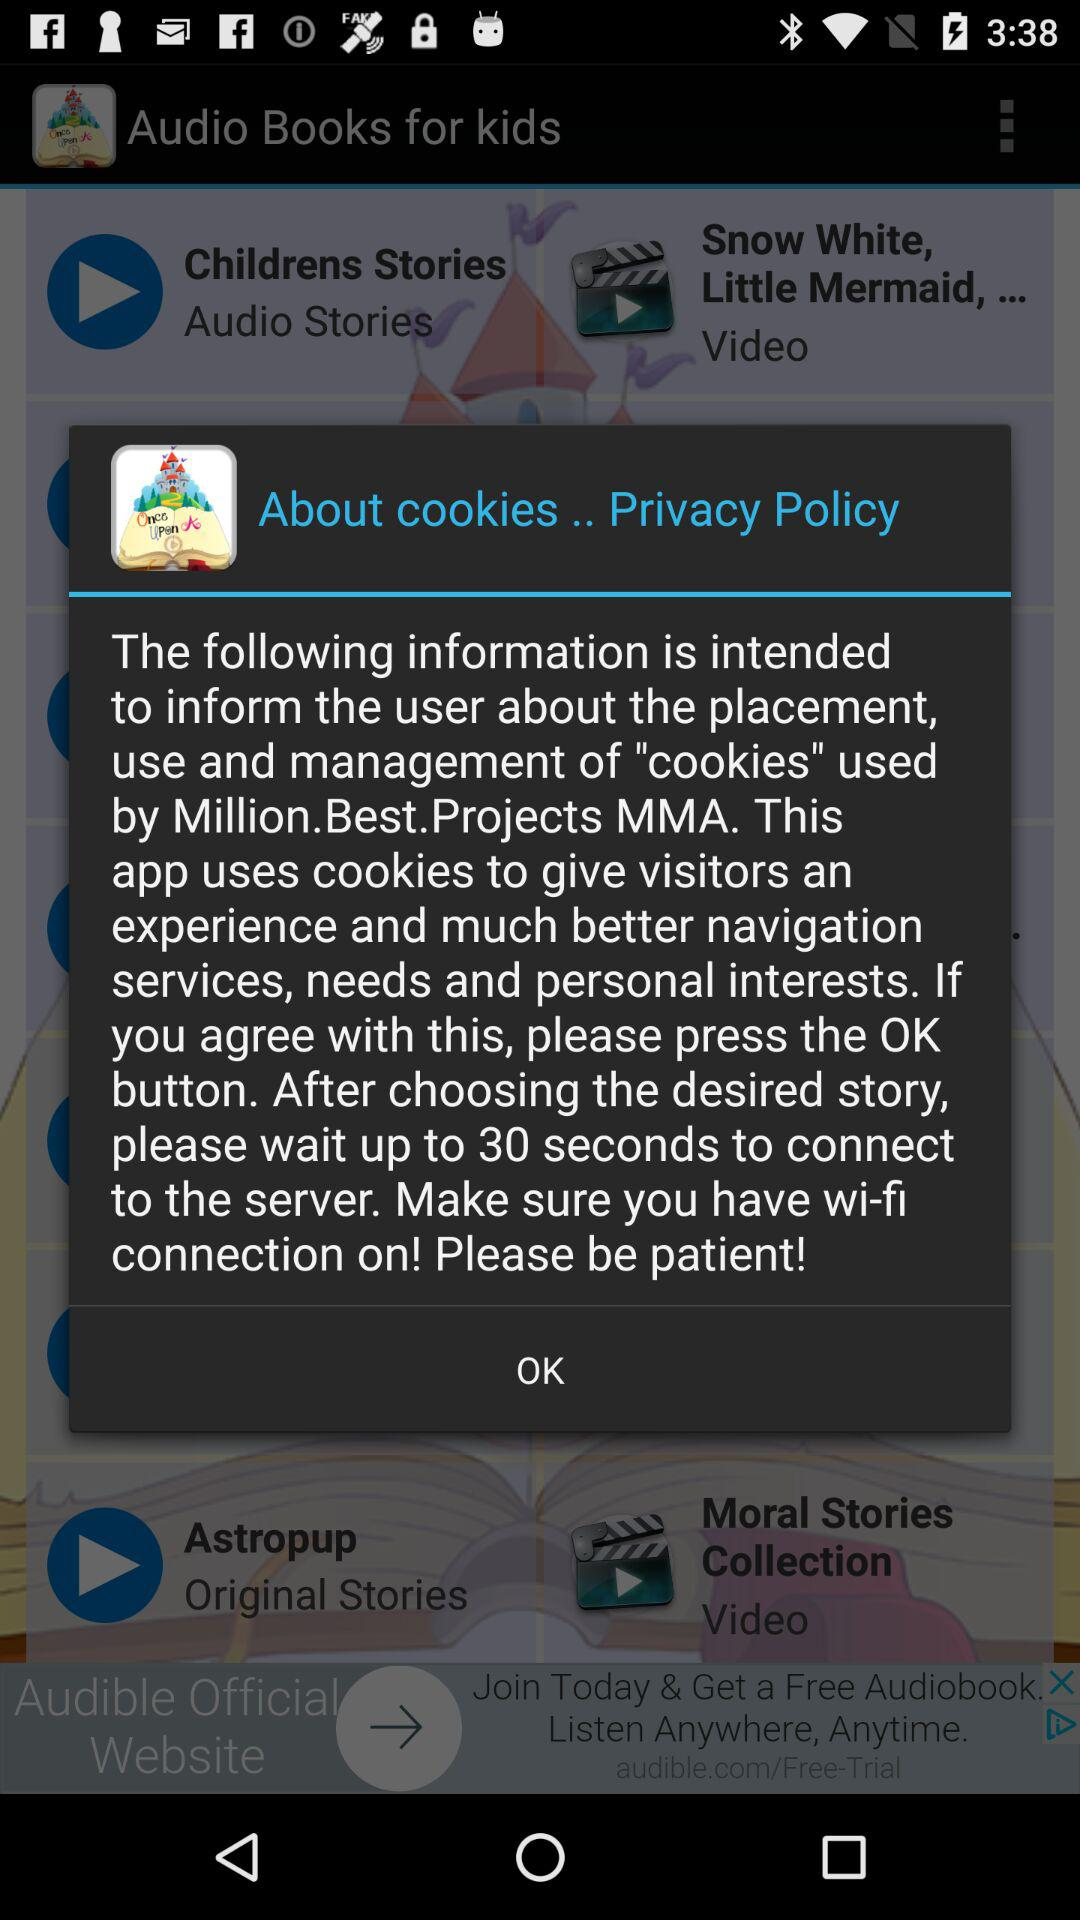Is the user's Wi-Fi connection turned on?
When the provided information is insufficient, respond with <no answer>. <no answer> 